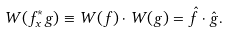<formula> <loc_0><loc_0><loc_500><loc_500>W ( f ^ { * } _ { x } g ) \equiv W ( f ) \cdot W ( g ) = \hat { f } \cdot \hat { g } .</formula> 